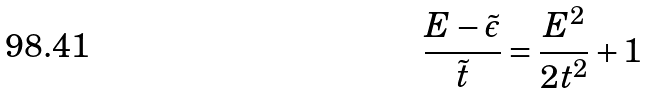<formula> <loc_0><loc_0><loc_500><loc_500>\frac { E - \tilde { \epsilon } } { \tilde { t } } = \frac { E ^ { 2 } } { 2 t ^ { 2 } } + 1</formula> 